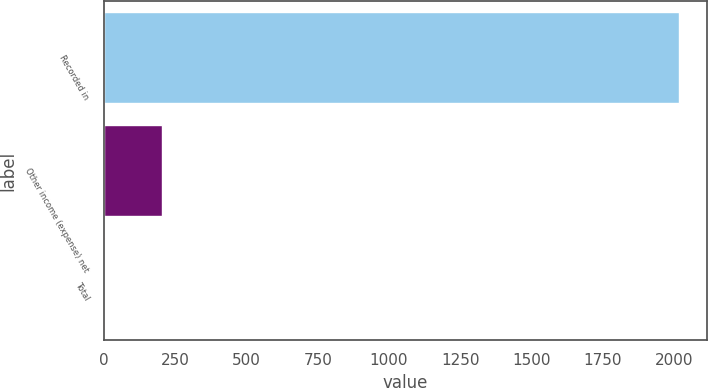<chart> <loc_0><loc_0><loc_500><loc_500><bar_chart><fcel>Recorded in<fcel>Other income (expense) net<fcel>Total<nl><fcel>2015<fcel>204.2<fcel>3<nl></chart> 